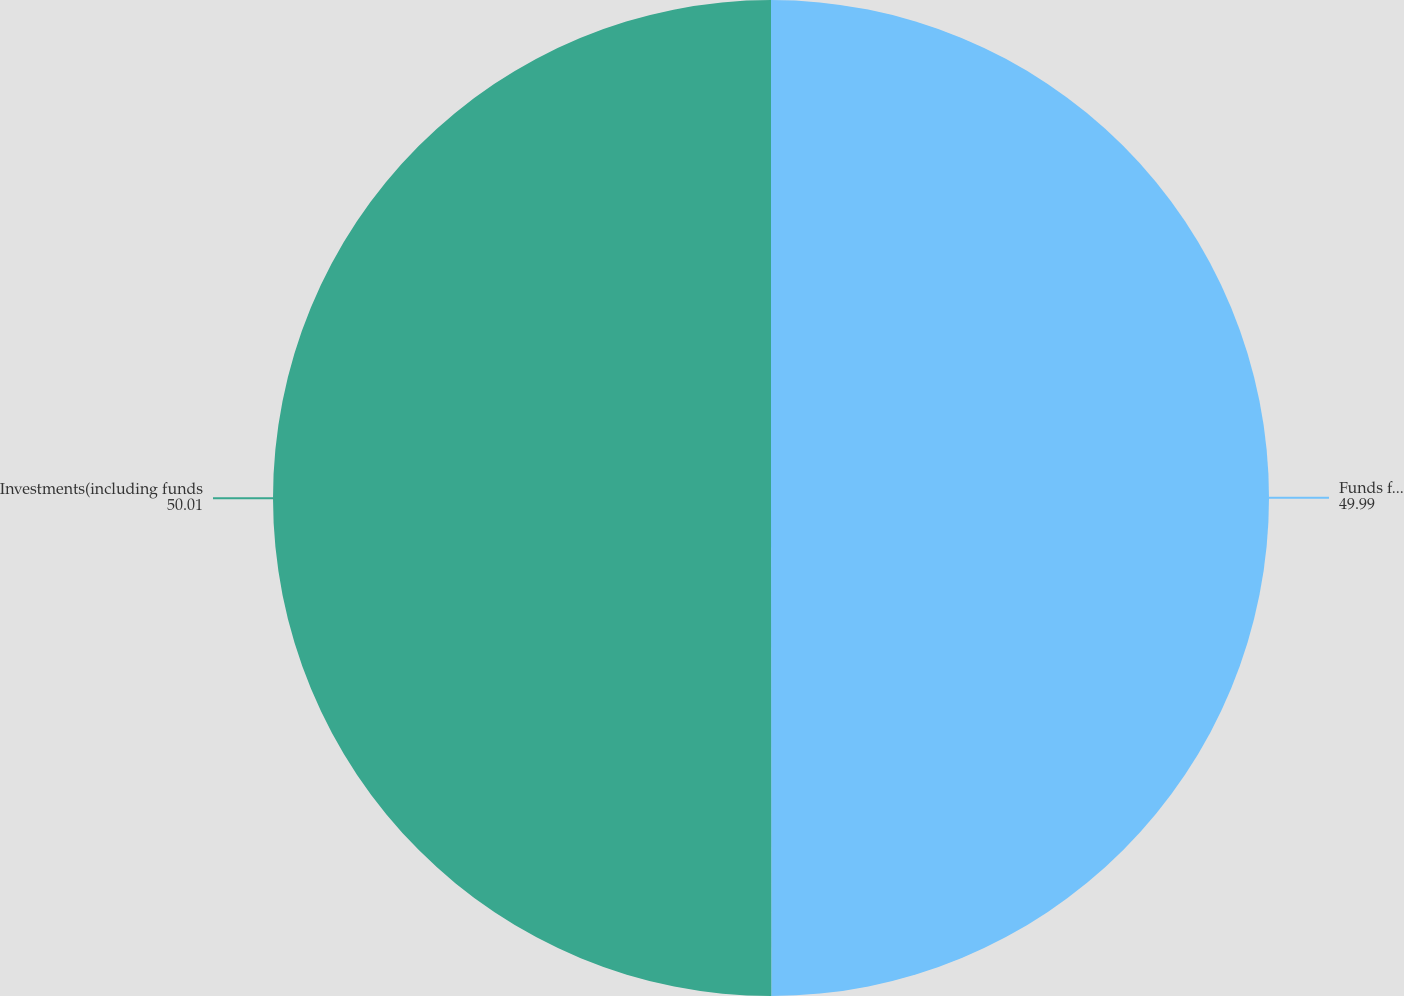Convert chart. <chart><loc_0><loc_0><loc_500><loc_500><pie_chart><fcel>Funds for retiree health<fcel>Investments(including funds<nl><fcel>49.99%<fcel>50.01%<nl></chart> 